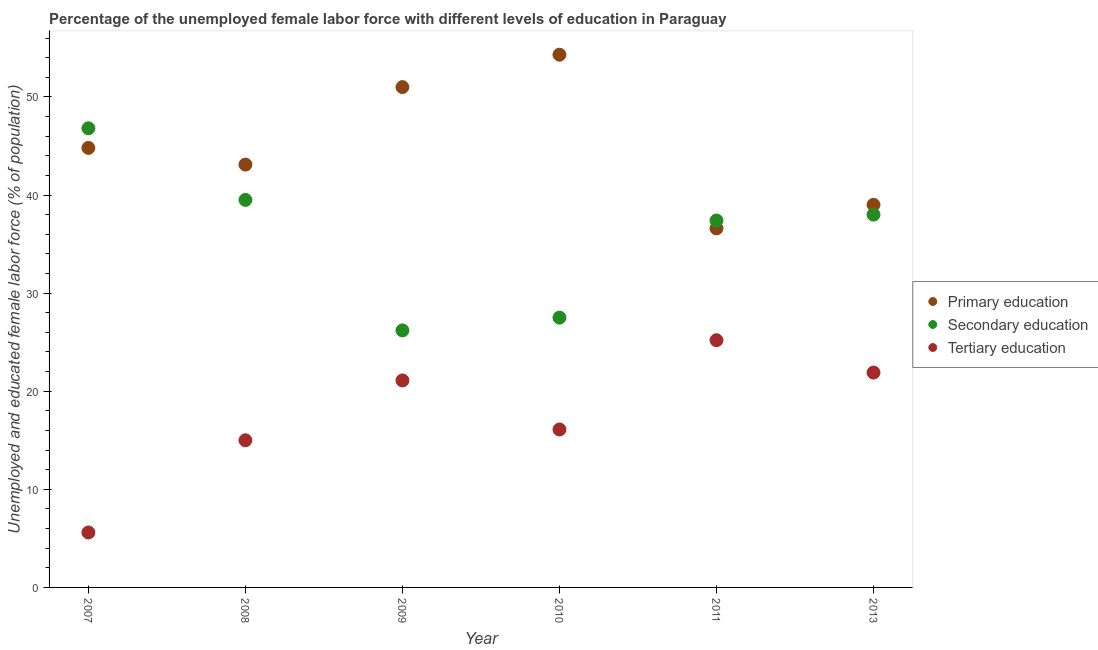How many different coloured dotlines are there?
Provide a succinct answer. 3. Is the number of dotlines equal to the number of legend labels?
Provide a short and direct response. Yes. Across all years, what is the maximum percentage of female labor force who received secondary education?
Provide a succinct answer. 46.8. Across all years, what is the minimum percentage of female labor force who received secondary education?
Make the answer very short. 26.2. In which year was the percentage of female labor force who received primary education maximum?
Provide a succinct answer. 2010. In which year was the percentage of female labor force who received secondary education minimum?
Provide a succinct answer. 2009. What is the total percentage of female labor force who received tertiary education in the graph?
Your answer should be compact. 104.9. What is the difference between the percentage of female labor force who received secondary education in 2008 and that in 2010?
Keep it short and to the point. 12. What is the difference between the percentage of female labor force who received primary education in 2011 and the percentage of female labor force who received tertiary education in 2007?
Ensure brevity in your answer.  31. What is the average percentage of female labor force who received secondary education per year?
Ensure brevity in your answer.  35.9. In how many years, is the percentage of female labor force who received tertiary education greater than 22 %?
Ensure brevity in your answer.  1. What is the ratio of the percentage of female labor force who received tertiary education in 2008 to that in 2013?
Your response must be concise. 0.68. Is the percentage of female labor force who received tertiary education in 2007 less than that in 2013?
Give a very brief answer. Yes. What is the difference between the highest and the second highest percentage of female labor force who received secondary education?
Give a very brief answer. 7.3. What is the difference between the highest and the lowest percentage of female labor force who received primary education?
Your answer should be compact. 17.7. In how many years, is the percentage of female labor force who received tertiary education greater than the average percentage of female labor force who received tertiary education taken over all years?
Provide a succinct answer. 3. Is it the case that in every year, the sum of the percentage of female labor force who received primary education and percentage of female labor force who received secondary education is greater than the percentage of female labor force who received tertiary education?
Provide a short and direct response. Yes. Does the percentage of female labor force who received secondary education monotonically increase over the years?
Offer a very short reply. No. Is the percentage of female labor force who received tertiary education strictly less than the percentage of female labor force who received secondary education over the years?
Give a very brief answer. Yes. How many dotlines are there?
Provide a short and direct response. 3. How many years are there in the graph?
Provide a short and direct response. 6. How are the legend labels stacked?
Your response must be concise. Vertical. What is the title of the graph?
Offer a terse response. Percentage of the unemployed female labor force with different levels of education in Paraguay. What is the label or title of the Y-axis?
Give a very brief answer. Unemployed and educated female labor force (% of population). What is the Unemployed and educated female labor force (% of population) in Primary education in 2007?
Provide a succinct answer. 44.8. What is the Unemployed and educated female labor force (% of population) of Secondary education in 2007?
Give a very brief answer. 46.8. What is the Unemployed and educated female labor force (% of population) of Tertiary education in 2007?
Provide a succinct answer. 5.6. What is the Unemployed and educated female labor force (% of population) in Primary education in 2008?
Keep it short and to the point. 43.1. What is the Unemployed and educated female labor force (% of population) in Secondary education in 2008?
Provide a short and direct response. 39.5. What is the Unemployed and educated female labor force (% of population) in Tertiary education in 2008?
Provide a short and direct response. 15. What is the Unemployed and educated female labor force (% of population) in Secondary education in 2009?
Ensure brevity in your answer.  26.2. What is the Unemployed and educated female labor force (% of population) in Tertiary education in 2009?
Keep it short and to the point. 21.1. What is the Unemployed and educated female labor force (% of population) of Primary education in 2010?
Your answer should be compact. 54.3. What is the Unemployed and educated female labor force (% of population) in Tertiary education in 2010?
Your response must be concise. 16.1. What is the Unemployed and educated female labor force (% of population) in Primary education in 2011?
Your response must be concise. 36.6. What is the Unemployed and educated female labor force (% of population) of Secondary education in 2011?
Give a very brief answer. 37.4. What is the Unemployed and educated female labor force (% of population) in Tertiary education in 2011?
Keep it short and to the point. 25.2. What is the Unemployed and educated female labor force (% of population) in Primary education in 2013?
Ensure brevity in your answer.  39. What is the Unemployed and educated female labor force (% of population) in Secondary education in 2013?
Offer a terse response. 38. What is the Unemployed and educated female labor force (% of population) of Tertiary education in 2013?
Your answer should be compact. 21.9. Across all years, what is the maximum Unemployed and educated female labor force (% of population) in Primary education?
Provide a succinct answer. 54.3. Across all years, what is the maximum Unemployed and educated female labor force (% of population) in Secondary education?
Your answer should be compact. 46.8. Across all years, what is the maximum Unemployed and educated female labor force (% of population) in Tertiary education?
Provide a succinct answer. 25.2. Across all years, what is the minimum Unemployed and educated female labor force (% of population) of Primary education?
Give a very brief answer. 36.6. Across all years, what is the minimum Unemployed and educated female labor force (% of population) in Secondary education?
Give a very brief answer. 26.2. Across all years, what is the minimum Unemployed and educated female labor force (% of population) of Tertiary education?
Keep it short and to the point. 5.6. What is the total Unemployed and educated female labor force (% of population) of Primary education in the graph?
Keep it short and to the point. 268.8. What is the total Unemployed and educated female labor force (% of population) of Secondary education in the graph?
Keep it short and to the point. 215.4. What is the total Unemployed and educated female labor force (% of population) in Tertiary education in the graph?
Your answer should be compact. 104.9. What is the difference between the Unemployed and educated female labor force (% of population) in Primary education in 2007 and that in 2008?
Give a very brief answer. 1.7. What is the difference between the Unemployed and educated female labor force (% of population) in Secondary education in 2007 and that in 2008?
Your answer should be compact. 7.3. What is the difference between the Unemployed and educated female labor force (% of population) in Primary education in 2007 and that in 2009?
Provide a short and direct response. -6.2. What is the difference between the Unemployed and educated female labor force (% of population) in Secondary education in 2007 and that in 2009?
Your answer should be very brief. 20.6. What is the difference between the Unemployed and educated female labor force (% of population) of Tertiary education in 2007 and that in 2009?
Make the answer very short. -15.5. What is the difference between the Unemployed and educated female labor force (% of population) of Secondary education in 2007 and that in 2010?
Offer a very short reply. 19.3. What is the difference between the Unemployed and educated female labor force (% of population) in Secondary education in 2007 and that in 2011?
Ensure brevity in your answer.  9.4. What is the difference between the Unemployed and educated female labor force (% of population) in Tertiary education in 2007 and that in 2011?
Your response must be concise. -19.6. What is the difference between the Unemployed and educated female labor force (% of population) of Tertiary education in 2007 and that in 2013?
Offer a terse response. -16.3. What is the difference between the Unemployed and educated female labor force (% of population) of Primary education in 2008 and that in 2009?
Your answer should be compact. -7.9. What is the difference between the Unemployed and educated female labor force (% of population) in Tertiary education in 2008 and that in 2009?
Keep it short and to the point. -6.1. What is the difference between the Unemployed and educated female labor force (% of population) of Secondary education in 2008 and that in 2010?
Your answer should be very brief. 12. What is the difference between the Unemployed and educated female labor force (% of population) of Tertiary education in 2008 and that in 2011?
Your answer should be compact. -10.2. What is the difference between the Unemployed and educated female labor force (% of population) of Primary education in 2008 and that in 2013?
Make the answer very short. 4.1. What is the difference between the Unemployed and educated female labor force (% of population) in Secondary education in 2009 and that in 2010?
Offer a terse response. -1.3. What is the difference between the Unemployed and educated female labor force (% of population) in Tertiary education in 2009 and that in 2010?
Make the answer very short. 5. What is the difference between the Unemployed and educated female labor force (% of population) of Primary education in 2009 and that in 2011?
Give a very brief answer. 14.4. What is the difference between the Unemployed and educated female labor force (% of population) in Secondary education in 2009 and that in 2011?
Your answer should be compact. -11.2. What is the difference between the Unemployed and educated female labor force (% of population) in Tertiary education in 2009 and that in 2011?
Give a very brief answer. -4.1. What is the difference between the Unemployed and educated female labor force (% of population) in Primary education in 2009 and that in 2013?
Offer a terse response. 12. What is the difference between the Unemployed and educated female labor force (% of population) in Tertiary education in 2009 and that in 2013?
Your response must be concise. -0.8. What is the difference between the Unemployed and educated female labor force (% of population) in Primary education in 2010 and that in 2011?
Provide a succinct answer. 17.7. What is the difference between the Unemployed and educated female labor force (% of population) of Secondary education in 2010 and that in 2013?
Offer a terse response. -10.5. What is the difference between the Unemployed and educated female labor force (% of population) of Tertiary education in 2010 and that in 2013?
Offer a very short reply. -5.8. What is the difference between the Unemployed and educated female labor force (% of population) in Primary education in 2011 and that in 2013?
Your response must be concise. -2.4. What is the difference between the Unemployed and educated female labor force (% of population) in Primary education in 2007 and the Unemployed and educated female labor force (% of population) in Secondary education in 2008?
Your answer should be compact. 5.3. What is the difference between the Unemployed and educated female labor force (% of population) of Primary education in 2007 and the Unemployed and educated female labor force (% of population) of Tertiary education in 2008?
Your answer should be compact. 29.8. What is the difference between the Unemployed and educated female labor force (% of population) of Secondary education in 2007 and the Unemployed and educated female labor force (% of population) of Tertiary education in 2008?
Offer a terse response. 31.8. What is the difference between the Unemployed and educated female labor force (% of population) in Primary education in 2007 and the Unemployed and educated female labor force (% of population) in Tertiary education in 2009?
Ensure brevity in your answer.  23.7. What is the difference between the Unemployed and educated female labor force (% of population) in Secondary education in 2007 and the Unemployed and educated female labor force (% of population) in Tertiary education in 2009?
Provide a short and direct response. 25.7. What is the difference between the Unemployed and educated female labor force (% of population) of Primary education in 2007 and the Unemployed and educated female labor force (% of population) of Secondary education in 2010?
Offer a very short reply. 17.3. What is the difference between the Unemployed and educated female labor force (% of population) of Primary education in 2007 and the Unemployed and educated female labor force (% of population) of Tertiary education in 2010?
Your response must be concise. 28.7. What is the difference between the Unemployed and educated female labor force (% of population) of Secondary education in 2007 and the Unemployed and educated female labor force (% of population) of Tertiary education in 2010?
Your answer should be very brief. 30.7. What is the difference between the Unemployed and educated female labor force (% of population) in Primary education in 2007 and the Unemployed and educated female labor force (% of population) in Secondary education in 2011?
Your answer should be very brief. 7.4. What is the difference between the Unemployed and educated female labor force (% of population) of Primary education in 2007 and the Unemployed and educated female labor force (% of population) of Tertiary education in 2011?
Your answer should be very brief. 19.6. What is the difference between the Unemployed and educated female labor force (% of population) of Secondary education in 2007 and the Unemployed and educated female labor force (% of population) of Tertiary education in 2011?
Offer a very short reply. 21.6. What is the difference between the Unemployed and educated female labor force (% of population) in Primary education in 2007 and the Unemployed and educated female labor force (% of population) in Secondary education in 2013?
Provide a short and direct response. 6.8. What is the difference between the Unemployed and educated female labor force (% of population) of Primary education in 2007 and the Unemployed and educated female labor force (% of population) of Tertiary education in 2013?
Offer a terse response. 22.9. What is the difference between the Unemployed and educated female labor force (% of population) of Secondary education in 2007 and the Unemployed and educated female labor force (% of population) of Tertiary education in 2013?
Your response must be concise. 24.9. What is the difference between the Unemployed and educated female labor force (% of population) of Primary education in 2008 and the Unemployed and educated female labor force (% of population) of Secondary education in 2009?
Make the answer very short. 16.9. What is the difference between the Unemployed and educated female labor force (% of population) in Primary education in 2008 and the Unemployed and educated female labor force (% of population) in Tertiary education in 2009?
Ensure brevity in your answer.  22. What is the difference between the Unemployed and educated female labor force (% of population) in Secondary education in 2008 and the Unemployed and educated female labor force (% of population) in Tertiary education in 2010?
Your answer should be very brief. 23.4. What is the difference between the Unemployed and educated female labor force (% of population) of Primary education in 2008 and the Unemployed and educated female labor force (% of population) of Tertiary education in 2011?
Your answer should be very brief. 17.9. What is the difference between the Unemployed and educated female labor force (% of population) in Secondary education in 2008 and the Unemployed and educated female labor force (% of population) in Tertiary education in 2011?
Make the answer very short. 14.3. What is the difference between the Unemployed and educated female labor force (% of population) of Primary education in 2008 and the Unemployed and educated female labor force (% of population) of Tertiary education in 2013?
Offer a very short reply. 21.2. What is the difference between the Unemployed and educated female labor force (% of population) of Secondary education in 2008 and the Unemployed and educated female labor force (% of population) of Tertiary education in 2013?
Provide a short and direct response. 17.6. What is the difference between the Unemployed and educated female labor force (% of population) in Primary education in 2009 and the Unemployed and educated female labor force (% of population) in Tertiary education in 2010?
Provide a succinct answer. 34.9. What is the difference between the Unemployed and educated female labor force (% of population) of Secondary education in 2009 and the Unemployed and educated female labor force (% of population) of Tertiary education in 2010?
Your response must be concise. 10.1. What is the difference between the Unemployed and educated female labor force (% of population) in Primary education in 2009 and the Unemployed and educated female labor force (% of population) in Secondary education in 2011?
Ensure brevity in your answer.  13.6. What is the difference between the Unemployed and educated female labor force (% of population) of Primary education in 2009 and the Unemployed and educated female labor force (% of population) of Tertiary education in 2011?
Provide a succinct answer. 25.8. What is the difference between the Unemployed and educated female labor force (% of population) in Primary education in 2009 and the Unemployed and educated female labor force (% of population) in Tertiary education in 2013?
Offer a terse response. 29.1. What is the difference between the Unemployed and educated female labor force (% of population) of Primary education in 2010 and the Unemployed and educated female labor force (% of population) of Secondary education in 2011?
Offer a very short reply. 16.9. What is the difference between the Unemployed and educated female labor force (% of population) in Primary education in 2010 and the Unemployed and educated female labor force (% of population) in Tertiary education in 2011?
Keep it short and to the point. 29.1. What is the difference between the Unemployed and educated female labor force (% of population) of Primary education in 2010 and the Unemployed and educated female labor force (% of population) of Tertiary education in 2013?
Provide a succinct answer. 32.4. What is the difference between the Unemployed and educated female labor force (% of population) of Primary education in 2011 and the Unemployed and educated female labor force (% of population) of Secondary education in 2013?
Keep it short and to the point. -1.4. What is the average Unemployed and educated female labor force (% of population) of Primary education per year?
Your answer should be compact. 44.8. What is the average Unemployed and educated female labor force (% of population) in Secondary education per year?
Your answer should be compact. 35.9. What is the average Unemployed and educated female labor force (% of population) in Tertiary education per year?
Offer a terse response. 17.48. In the year 2007, what is the difference between the Unemployed and educated female labor force (% of population) in Primary education and Unemployed and educated female labor force (% of population) in Secondary education?
Your answer should be compact. -2. In the year 2007, what is the difference between the Unemployed and educated female labor force (% of population) in Primary education and Unemployed and educated female labor force (% of population) in Tertiary education?
Offer a very short reply. 39.2. In the year 2007, what is the difference between the Unemployed and educated female labor force (% of population) in Secondary education and Unemployed and educated female labor force (% of population) in Tertiary education?
Give a very brief answer. 41.2. In the year 2008, what is the difference between the Unemployed and educated female labor force (% of population) of Primary education and Unemployed and educated female labor force (% of population) of Tertiary education?
Offer a very short reply. 28.1. In the year 2009, what is the difference between the Unemployed and educated female labor force (% of population) in Primary education and Unemployed and educated female labor force (% of population) in Secondary education?
Give a very brief answer. 24.8. In the year 2009, what is the difference between the Unemployed and educated female labor force (% of population) of Primary education and Unemployed and educated female labor force (% of population) of Tertiary education?
Your response must be concise. 29.9. In the year 2010, what is the difference between the Unemployed and educated female labor force (% of population) in Primary education and Unemployed and educated female labor force (% of population) in Secondary education?
Make the answer very short. 26.8. In the year 2010, what is the difference between the Unemployed and educated female labor force (% of population) of Primary education and Unemployed and educated female labor force (% of population) of Tertiary education?
Keep it short and to the point. 38.2. In the year 2011, what is the difference between the Unemployed and educated female labor force (% of population) of Primary education and Unemployed and educated female labor force (% of population) of Secondary education?
Offer a terse response. -0.8. In the year 2011, what is the difference between the Unemployed and educated female labor force (% of population) in Primary education and Unemployed and educated female labor force (% of population) in Tertiary education?
Offer a terse response. 11.4. In the year 2013, what is the difference between the Unemployed and educated female labor force (% of population) of Secondary education and Unemployed and educated female labor force (% of population) of Tertiary education?
Ensure brevity in your answer.  16.1. What is the ratio of the Unemployed and educated female labor force (% of population) in Primary education in 2007 to that in 2008?
Your answer should be compact. 1.04. What is the ratio of the Unemployed and educated female labor force (% of population) of Secondary education in 2007 to that in 2008?
Provide a succinct answer. 1.18. What is the ratio of the Unemployed and educated female labor force (% of population) of Tertiary education in 2007 to that in 2008?
Your response must be concise. 0.37. What is the ratio of the Unemployed and educated female labor force (% of population) in Primary education in 2007 to that in 2009?
Provide a short and direct response. 0.88. What is the ratio of the Unemployed and educated female labor force (% of population) in Secondary education in 2007 to that in 2009?
Keep it short and to the point. 1.79. What is the ratio of the Unemployed and educated female labor force (% of population) in Tertiary education in 2007 to that in 2009?
Provide a short and direct response. 0.27. What is the ratio of the Unemployed and educated female labor force (% of population) in Primary education in 2007 to that in 2010?
Offer a terse response. 0.82. What is the ratio of the Unemployed and educated female labor force (% of population) of Secondary education in 2007 to that in 2010?
Offer a terse response. 1.7. What is the ratio of the Unemployed and educated female labor force (% of population) of Tertiary education in 2007 to that in 2010?
Offer a terse response. 0.35. What is the ratio of the Unemployed and educated female labor force (% of population) of Primary education in 2007 to that in 2011?
Provide a short and direct response. 1.22. What is the ratio of the Unemployed and educated female labor force (% of population) in Secondary education in 2007 to that in 2011?
Offer a very short reply. 1.25. What is the ratio of the Unemployed and educated female labor force (% of population) in Tertiary education in 2007 to that in 2011?
Offer a terse response. 0.22. What is the ratio of the Unemployed and educated female labor force (% of population) of Primary education in 2007 to that in 2013?
Provide a succinct answer. 1.15. What is the ratio of the Unemployed and educated female labor force (% of population) of Secondary education in 2007 to that in 2013?
Give a very brief answer. 1.23. What is the ratio of the Unemployed and educated female labor force (% of population) in Tertiary education in 2007 to that in 2013?
Offer a very short reply. 0.26. What is the ratio of the Unemployed and educated female labor force (% of population) of Primary education in 2008 to that in 2009?
Provide a succinct answer. 0.85. What is the ratio of the Unemployed and educated female labor force (% of population) of Secondary education in 2008 to that in 2009?
Give a very brief answer. 1.51. What is the ratio of the Unemployed and educated female labor force (% of population) in Tertiary education in 2008 to that in 2009?
Make the answer very short. 0.71. What is the ratio of the Unemployed and educated female labor force (% of population) in Primary education in 2008 to that in 2010?
Your answer should be compact. 0.79. What is the ratio of the Unemployed and educated female labor force (% of population) in Secondary education in 2008 to that in 2010?
Your answer should be very brief. 1.44. What is the ratio of the Unemployed and educated female labor force (% of population) of Tertiary education in 2008 to that in 2010?
Give a very brief answer. 0.93. What is the ratio of the Unemployed and educated female labor force (% of population) in Primary education in 2008 to that in 2011?
Give a very brief answer. 1.18. What is the ratio of the Unemployed and educated female labor force (% of population) of Secondary education in 2008 to that in 2011?
Provide a succinct answer. 1.06. What is the ratio of the Unemployed and educated female labor force (% of population) in Tertiary education in 2008 to that in 2011?
Ensure brevity in your answer.  0.6. What is the ratio of the Unemployed and educated female labor force (% of population) of Primary education in 2008 to that in 2013?
Provide a short and direct response. 1.11. What is the ratio of the Unemployed and educated female labor force (% of population) of Secondary education in 2008 to that in 2013?
Keep it short and to the point. 1.04. What is the ratio of the Unemployed and educated female labor force (% of population) of Tertiary education in 2008 to that in 2013?
Your answer should be very brief. 0.68. What is the ratio of the Unemployed and educated female labor force (% of population) in Primary education in 2009 to that in 2010?
Offer a terse response. 0.94. What is the ratio of the Unemployed and educated female labor force (% of population) in Secondary education in 2009 to that in 2010?
Ensure brevity in your answer.  0.95. What is the ratio of the Unemployed and educated female labor force (% of population) of Tertiary education in 2009 to that in 2010?
Keep it short and to the point. 1.31. What is the ratio of the Unemployed and educated female labor force (% of population) in Primary education in 2009 to that in 2011?
Your answer should be compact. 1.39. What is the ratio of the Unemployed and educated female labor force (% of population) of Secondary education in 2009 to that in 2011?
Provide a short and direct response. 0.7. What is the ratio of the Unemployed and educated female labor force (% of population) of Tertiary education in 2009 to that in 2011?
Offer a very short reply. 0.84. What is the ratio of the Unemployed and educated female labor force (% of population) in Primary education in 2009 to that in 2013?
Your answer should be compact. 1.31. What is the ratio of the Unemployed and educated female labor force (% of population) of Secondary education in 2009 to that in 2013?
Your answer should be compact. 0.69. What is the ratio of the Unemployed and educated female labor force (% of population) in Tertiary education in 2009 to that in 2013?
Give a very brief answer. 0.96. What is the ratio of the Unemployed and educated female labor force (% of population) in Primary education in 2010 to that in 2011?
Your answer should be very brief. 1.48. What is the ratio of the Unemployed and educated female labor force (% of population) in Secondary education in 2010 to that in 2011?
Provide a short and direct response. 0.74. What is the ratio of the Unemployed and educated female labor force (% of population) of Tertiary education in 2010 to that in 2011?
Keep it short and to the point. 0.64. What is the ratio of the Unemployed and educated female labor force (% of population) of Primary education in 2010 to that in 2013?
Ensure brevity in your answer.  1.39. What is the ratio of the Unemployed and educated female labor force (% of population) of Secondary education in 2010 to that in 2013?
Offer a terse response. 0.72. What is the ratio of the Unemployed and educated female labor force (% of population) of Tertiary education in 2010 to that in 2013?
Offer a terse response. 0.74. What is the ratio of the Unemployed and educated female labor force (% of population) of Primary education in 2011 to that in 2013?
Offer a very short reply. 0.94. What is the ratio of the Unemployed and educated female labor force (% of population) of Secondary education in 2011 to that in 2013?
Provide a succinct answer. 0.98. What is the ratio of the Unemployed and educated female labor force (% of population) in Tertiary education in 2011 to that in 2013?
Provide a succinct answer. 1.15. What is the difference between the highest and the second highest Unemployed and educated female labor force (% of population) of Primary education?
Ensure brevity in your answer.  3.3. What is the difference between the highest and the second highest Unemployed and educated female labor force (% of population) of Tertiary education?
Ensure brevity in your answer.  3.3. What is the difference between the highest and the lowest Unemployed and educated female labor force (% of population) of Primary education?
Make the answer very short. 17.7. What is the difference between the highest and the lowest Unemployed and educated female labor force (% of population) of Secondary education?
Offer a terse response. 20.6. What is the difference between the highest and the lowest Unemployed and educated female labor force (% of population) of Tertiary education?
Make the answer very short. 19.6. 